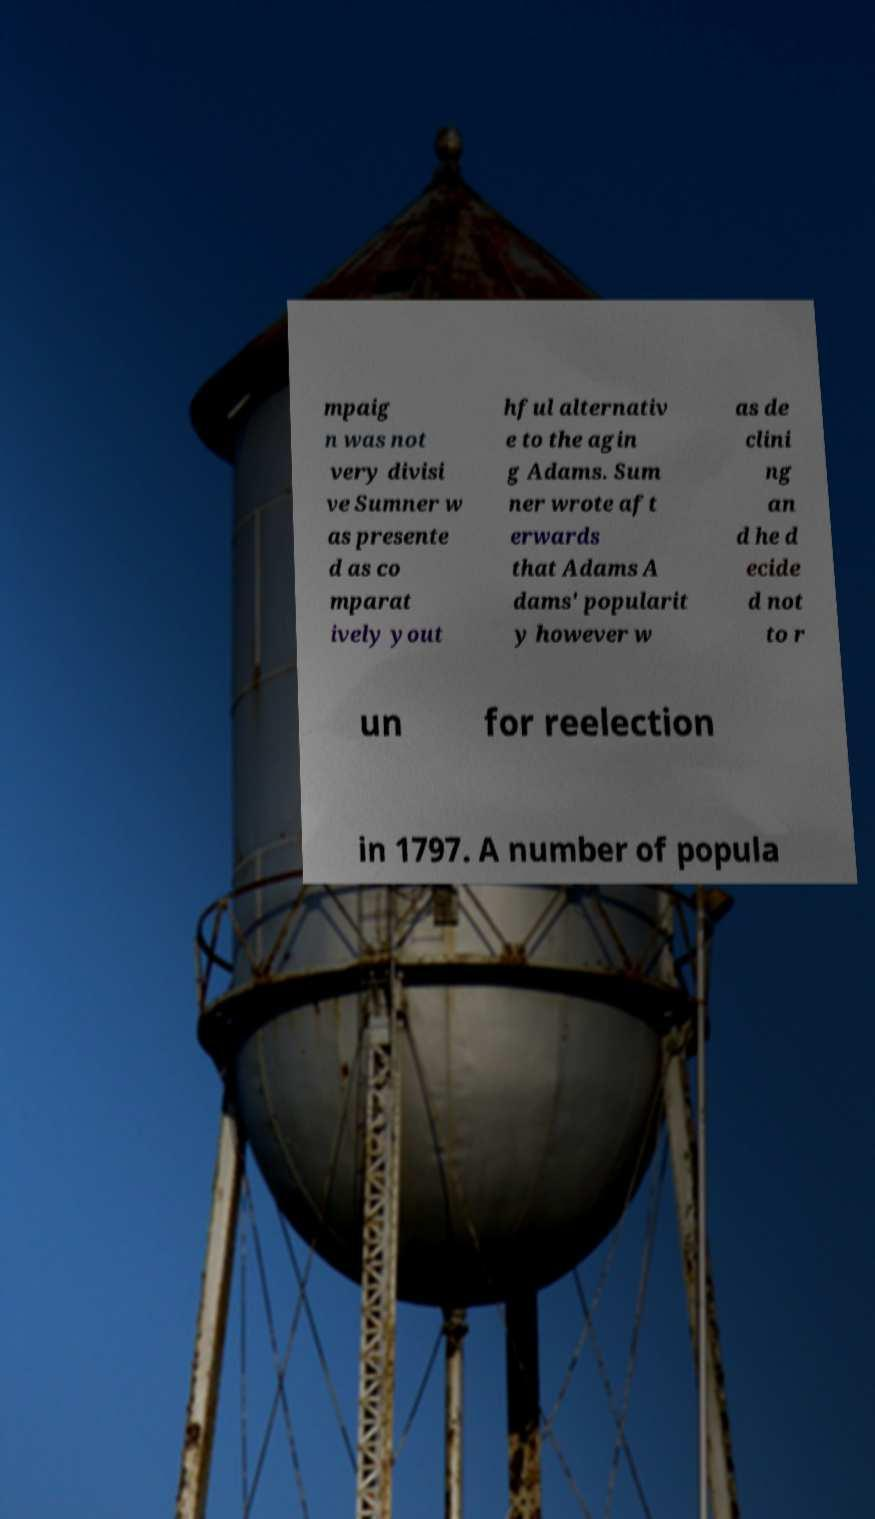Please identify and transcribe the text found in this image. mpaig n was not very divisi ve Sumner w as presente d as co mparat ively yout hful alternativ e to the agin g Adams. Sum ner wrote aft erwards that Adams A dams' popularit y however w as de clini ng an d he d ecide d not to r un for reelection in 1797. A number of popula 